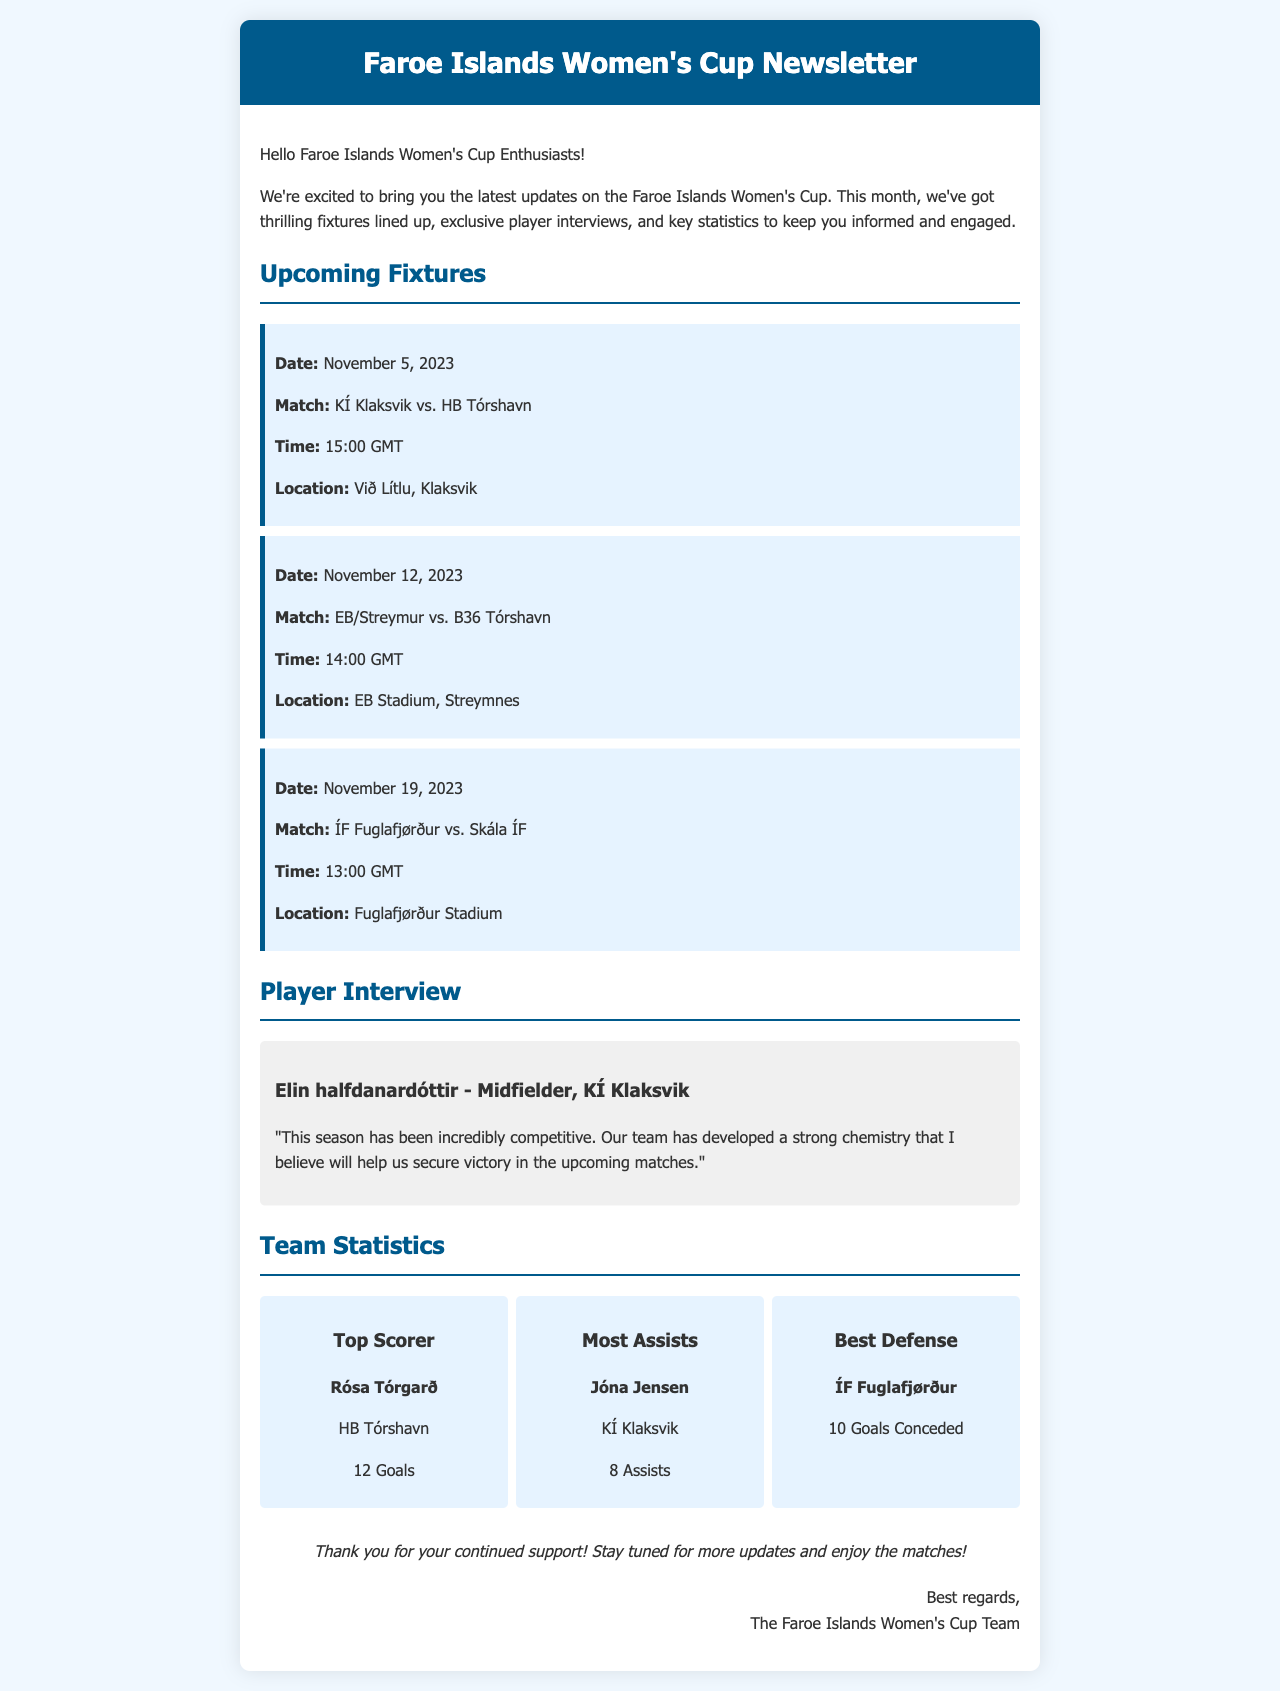What is the date of the KÍ Klaksvik vs. HB Tórshavn match? The date of the match is mentioned in the fixtures section of the document.
Answer: November 5, 2023 Who is the top scorer in the league? The document lists the top scorer under the team statistics section.
Answer: Rósa Tórgarð What is the time for the EB/Streymur vs. B36 Tórshavn match? The time for the match is specified in the fixtures section of the document.
Answer: 14:00 GMT How many assists does Jóna Jensen have? The document states the number of assists for Jóna Jensen in the team statistics section.
Answer: 8 Assists What team has the best defense? This information is provided in the team statistics section of the document.
Answer: ÍF Fuglafjørður What position does Elin halfdanardóttir play? The player's position is mentioned in her interview section.
Answer: Midfielder What is the location for the ÍF Fuglafjørður vs. Skála ÍF match? The location for the match is listed under the fixtures section.
Answer: Fuglafjørður Stadium Who wrote the newsletter? The document includes a section noting who the newsletter is from.
Answer: The Faroe Islands Women's Cup Team 